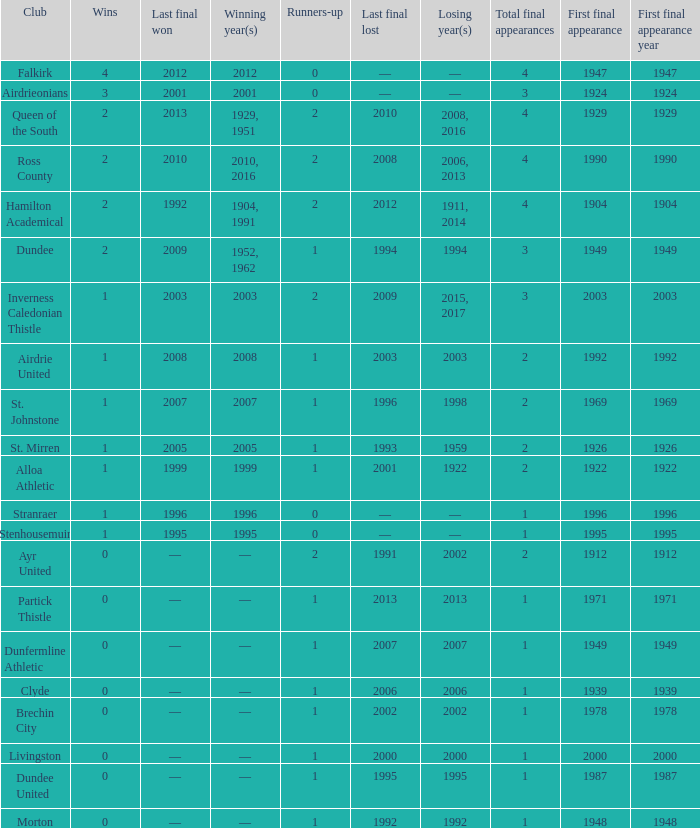How manywins for dunfermline athletic that has a total final appearances less than 2? 0.0. 